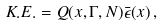Convert formula to latex. <formula><loc_0><loc_0><loc_500><loc_500>K . E . = Q ( x , \Gamma , N ) \bar { \epsilon } ( x ) \, ,</formula> 